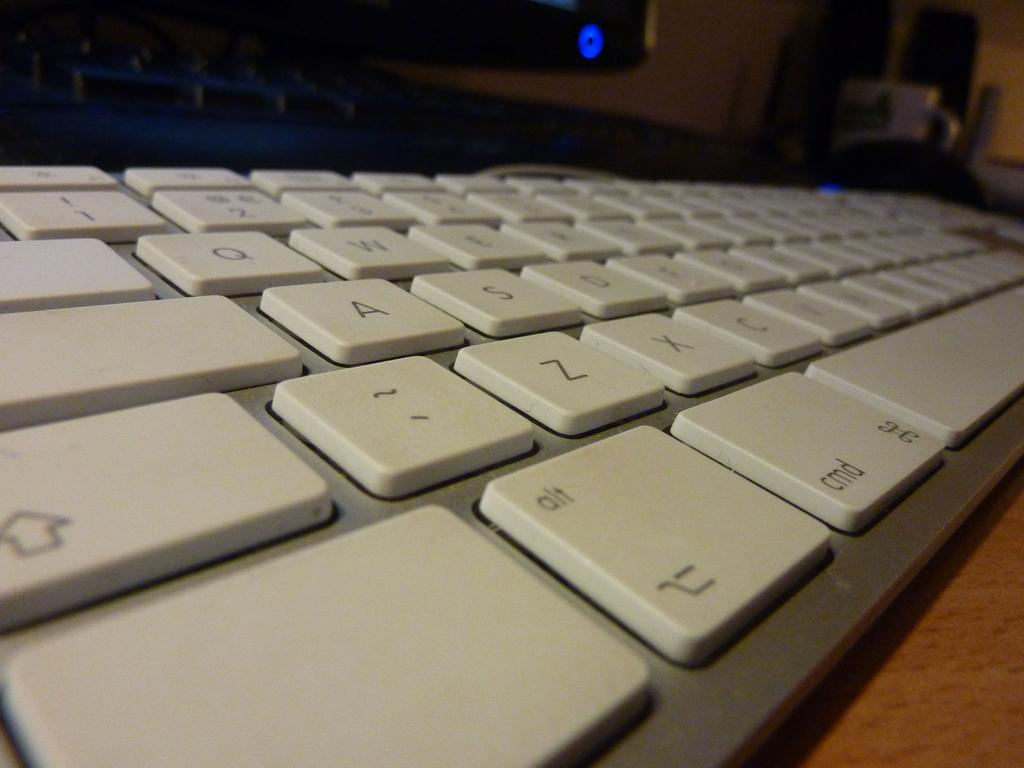What electronic device is visible in the image? There is a monitor in the image. What other device is present alongside the monitor? There is a keyboard in the image. Where are the monitor and keyboard located? Both the monitor and keyboard are on a table. What is the main topic of the conversation being held by the monitor and keyboard in the image? There is no conversation being held by the monitor and keyboard in the image, as they are inanimate objects. 